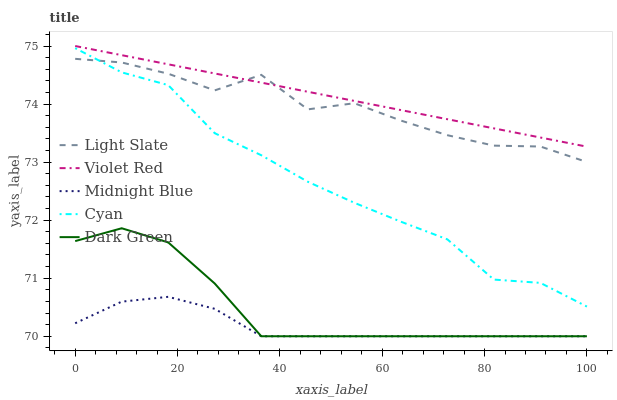Does Midnight Blue have the minimum area under the curve?
Answer yes or no. Yes. Does Violet Red have the maximum area under the curve?
Answer yes or no. Yes. Does Cyan have the minimum area under the curve?
Answer yes or no. No. Does Cyan have the maximum area under the curve?
Answer yes or no. No. Is Violet Red the smoothest?
Answer yes or no. Yes. Is Light Slate the roughest?
Answer yes or no. Yes. Is Cyan the smoothest?
Answer yes or no. No. Is Cyan the roughest?
Answer yes or no. No. Does Midnight Blue have the lowest value?
Answer yes or no. Yes. Does Cyan have the lowest value?
Answer yes or no. No. Does Violet Red have the highest value?
Answer yes or no. Yes. Does Cyan have the highest value?
Answer yes or no. No. Is Cyan less than Violet Red?
Answer yes or no. Yes. Is Violet Red greater than Cyan?
Answer yes or no. Yes. Does Dark Green intersect Midnight Blue?
Answer yes or no. Yes. Is Dark Green less than Midnight Blue?
Answer yes or no. No. Is Dark Green greater than Midnight Blue?
Answer yes or no. No. Does Cyan intersect Violet Red?
Answer yes or no. No. 